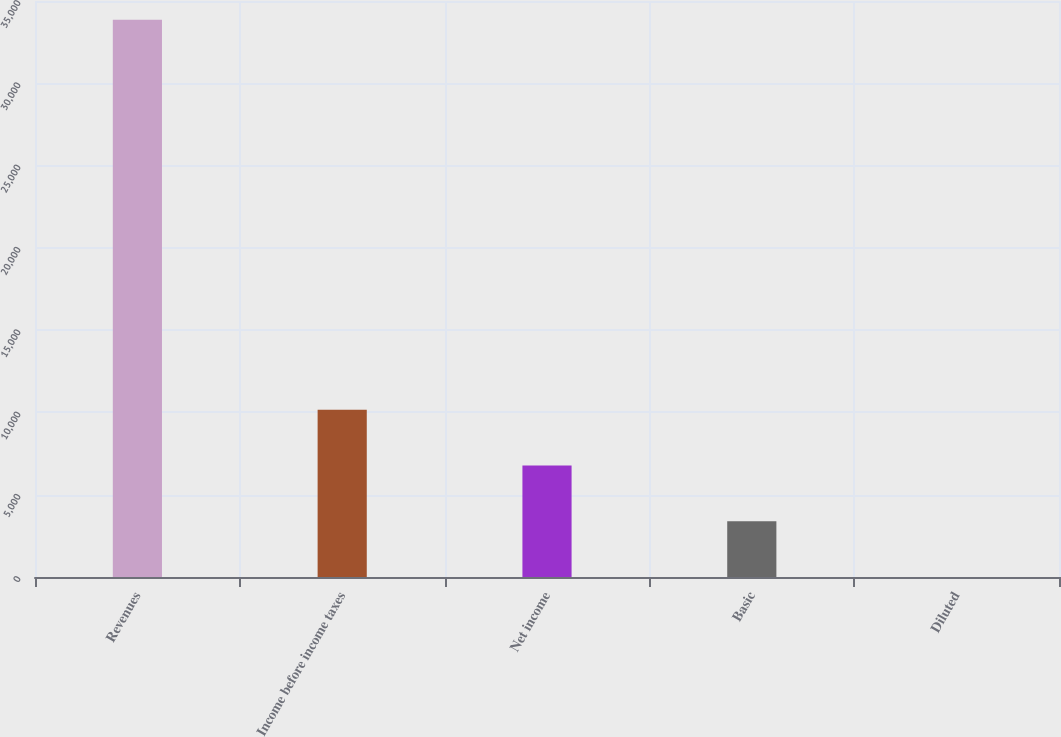<chart> <loc_0><loc_0><loc_500><loc_500><bar_chart><fcel>Revenues<fcel>Income before income taxes<fcel>Net income<fcel>Basic<fcel>Diluted<nl><fcel>33857<fcel>10157.3<fcel>6771.65<fcel>3385.98<fcel>0.31<nl></chart> 